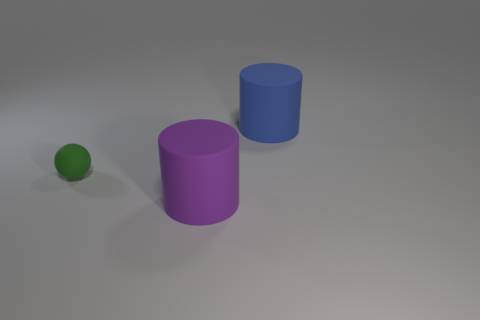Are there any other things that have the same size as the matte ball?
Provide a short and direct response. No. Is there anything else that is the same shape as the small matte thing?
Your response must be concise. No. Are there the same number of big blue things right of the tiny thing and large matte cylinders?
Your response must be concise. No. What number of tiny green rubber objects are the same shape as the purple thing?
Make the answer very short. 0. Is the shape of the large purple object the same as the blue thing?
Provide a succinct answer. Yes. What number of objects are cylinders that are left of the big blue rubber thing or tiny brown rubber cylinders?
Keep it short and to the point. 1. There is a large thing that is behind the large matte cylinder to the left of the blue thing that is behind the small rubber ball; what is its shape?
Make the answer very short. Cylinder. What shape is the other blue thing that is the same material as the tiny thing?
Your answer should be compact. Cylinder. The green matte thing is what size?
Offer a very short reply. Small. Do the sphere and the purple rubber cylinder have the same size?
Your answer should be compact. No. 